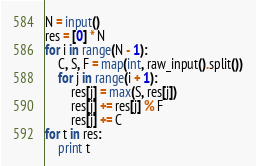<code> <loc_0><loc_0><loc_500><loc_500><_Python_>N = input()
res = [0] * N
for i in range(N - 1):
    C, S, F = map(int, raw_input().split())
    for j in range(i + 1):
        res[j] = max(S, res[j])
        res[j] += res[j] % F
        res[j] += C
for t in res:
    print t
</code> 